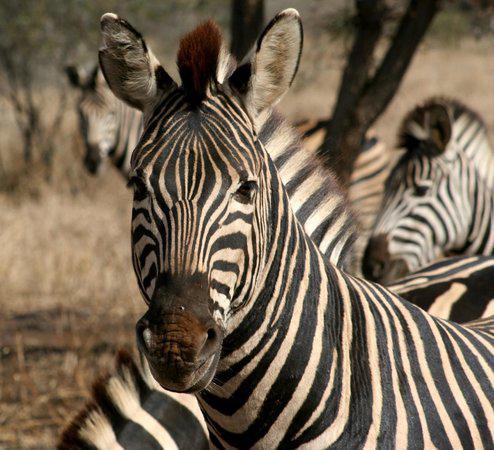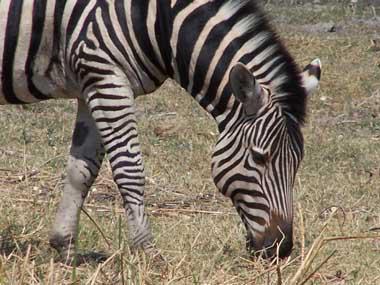The first image is the image on the left, the second image is the image on the right. Analyze the images presented: Is the assertion "Some zebras are in water." valid? Answer yes or no. No. The first image is the image on the left, the second image is the image on the right. Examine the images to the left and right. Is the description "The left image shows several forward-turned zebra in the foreground, and the right image includes several zebras standing in water." accurate? Answer yes or no. No. 